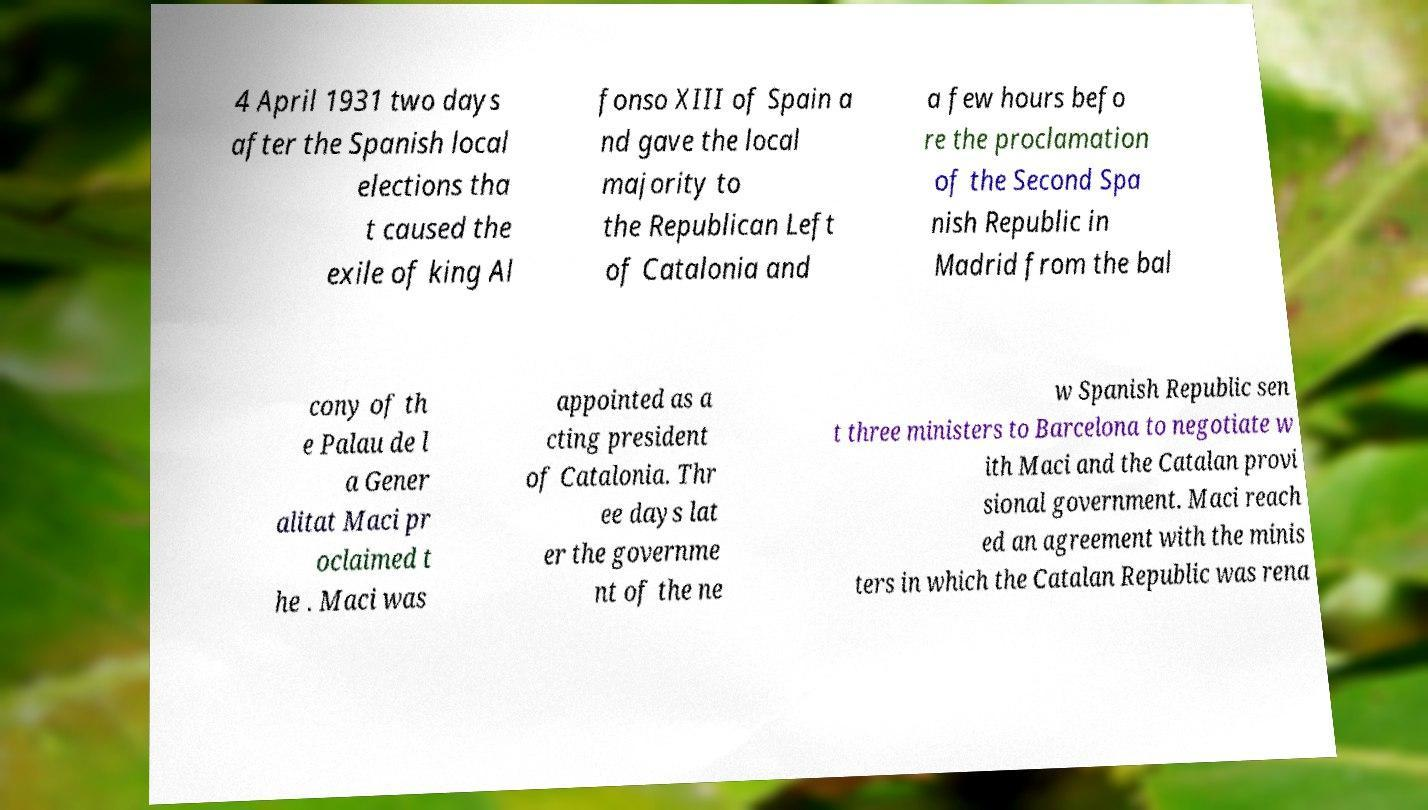Can you accurately transcribe the text from the provided image for me? 4 April 1931 two days after the Spanish local elections tha t caused the exile of king Al fonso XIII of Spain a nd gave the local majority to the Republican Left of Catalonia and a few hours befo re the proclamation of the Second Spa nish Republic in Madrid from the bal cony of th e Palau de l a Gener alitat Maci pr oclaimed t he . Maci was appointed as a cting president of Catalonia. Thr ee days lat er the governme nt of the ne w Spanish Republic sen t three ministers to Barcelona to negotiate w ith Maci and the Catalan provi sional government. Maci reach ed an agreement with the minis ters in which the Catalan Republic was rena 